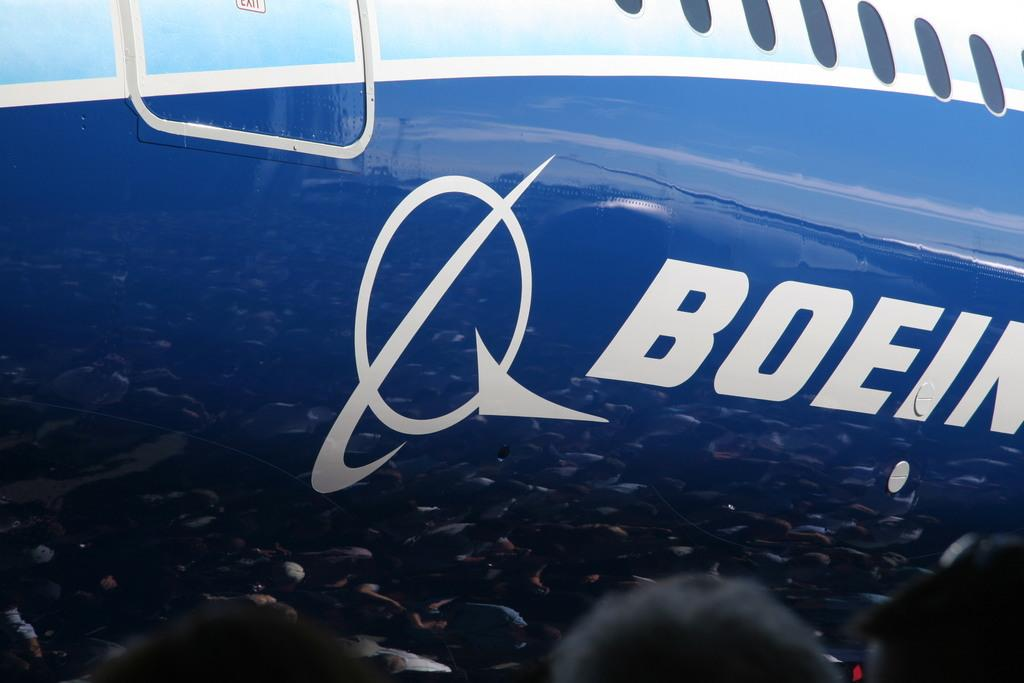<image>
Provide a brief description of the given image. A blue and white airplane with the word Boeing written on it. 